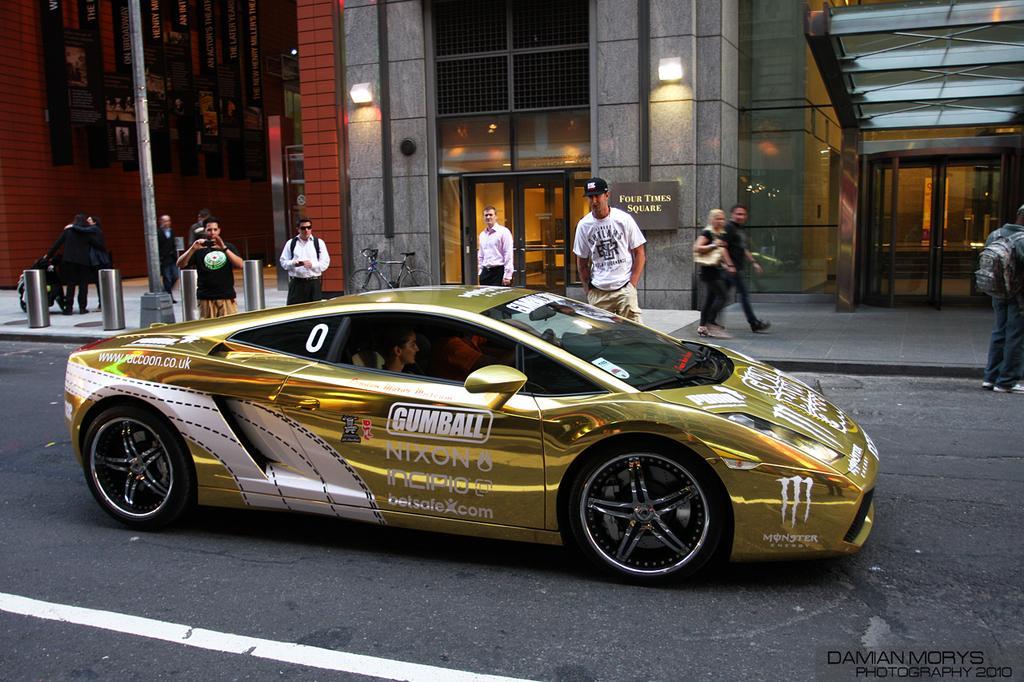Could you give a brief overview of what you see in this image? In this image we can see two persons are sitting in a car on the road. In the background there are few persons standing and walking on the footpath and a man is holding camera in his hand on the left side and we can see buildings, lights and boards on the wall, glass doors, pole and on the left side there are hoardings on the wall. 